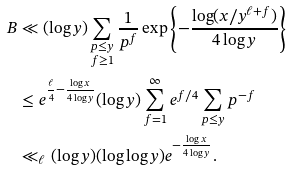<formula> <loc_0><loc_0><loc_500><loc_500>B & \ll ( \log y ) \sum _ { \substack { p \leq y \\ f \geq 1 } } \frac { 1 } { p ^ { f } } \exp \left \{ - \frac { \log ( x / y ^ { \ell + f } ) } { 4 \log y } \right \} \\ & \leq e ^ { \frac { \ell } { 4 } - \frac { \log x } { 4 \log y } } ( \log y ) \sum _ { f = 1 } ^ { \infty } e ^ { f / 4 } \sum _ { p \leq y } p ^ { - f } \\ & \ll _ { \ell } ( \log y ) ( \log \log y ) e ^ { - \frac { \log x } { 4 \log y } } .</formula> 